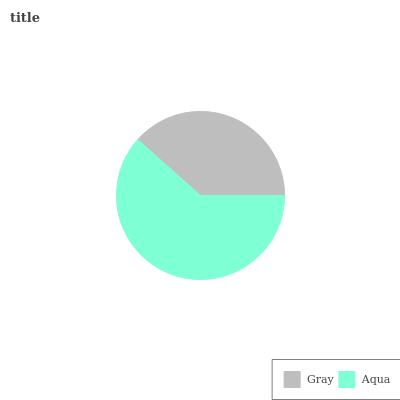Is Gray the minimum?
Answer yes or no. Yes. Is Aqua the maximum?
Answer yes or no. Yes. Is Aqua the minimum?
Answer yes or no. No. Is Aqua greater than Gray?
Answer yes or no. Yes. Is Gray less than Aqua?
Answer yes or no. Yes. Is Gray greater than Aqua?
Answer yes or no. No. Is Aqua less than Gray?
Answer yes or no. No. Is Aqua the high median?
Answer yes or no. Yes. Is Gray the low median?
Answer yes or no. Yes. Is Gray the high median?
Answer yes or no. No. Is Aqua the low median?
Answer yes or no. No. 